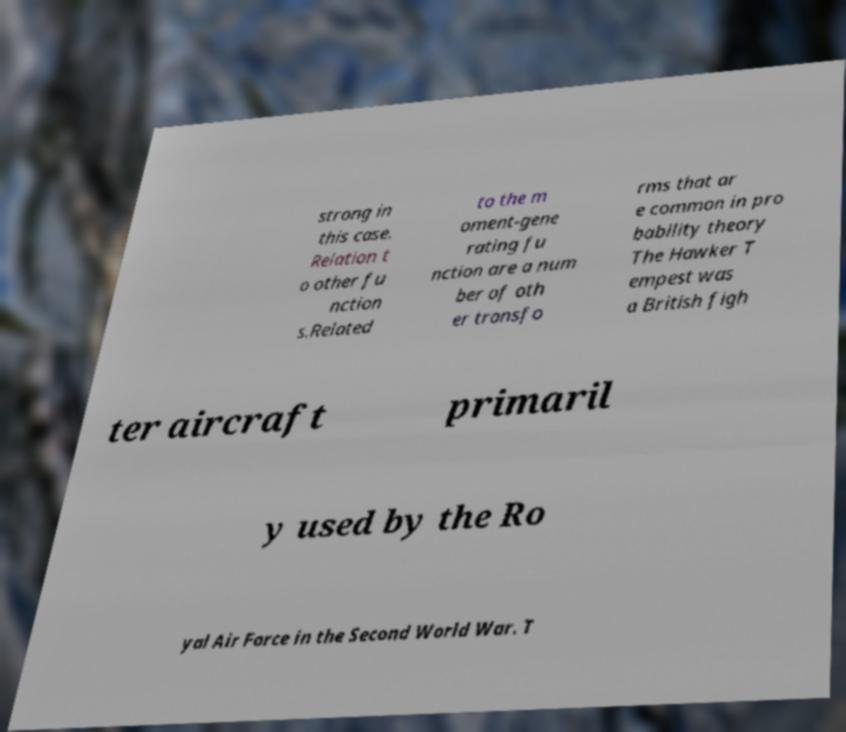Please identify and transcribe the text found in this image. strong in this case. Relation t o other fu nction s.Related to the m oment-gene rating fu nction are a num ber of oth er transfo rms that ar e common in pro bability theory The Hawker T empest was a British figh ter aircraft primaril y used by the Ro yal Air Force in the Second World War. T 